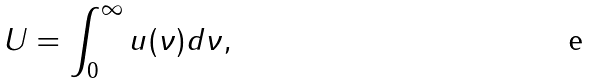<formula> <loc_0><loc_0><loc_500><loc_500>U = \int _ { 0 } ^ { \infty } u ( \nu ) d \nu ,</formula> 